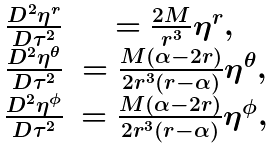<formula> <loc_0><loc_0><loc_500><loc_500>\begin{array} { c c c } \frac { D ^ { 2 } \eta ^ { r } } { D \tau ^ { 2 } } & = \frac { 2 M } { r ^ { 3 } } \eta ^ { r } , \\ \frac { D ^ { 2 } \eta ^ { \theta } } { D \tau ^ { 2 } } & = \frac { M ( { \alpha } - 2 r ) } { 2 r ^ { 3 } ( r - { \alpha } ) } \eta ^ { \theta } , \\ \frac { D ^ { 2 } \eta ^ { \phi } } { D \tau ^ { 2 } } & = \frac { M ( { \alpha } - 2 r ) } { 2 r ^ { 3 } ( r - { \alpha } ) } \eta ^ { \phi } , \end{array}</formula> 